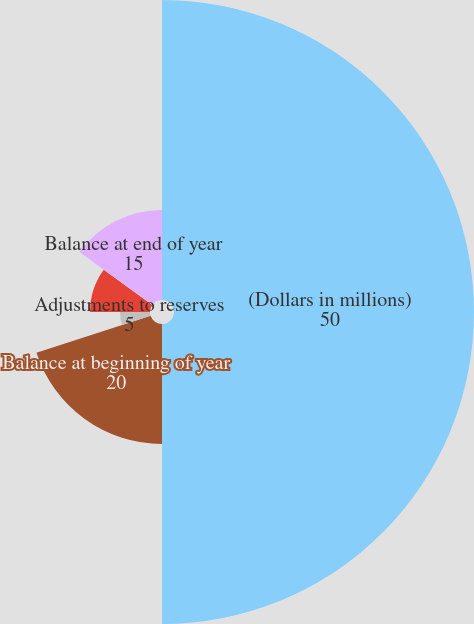Convert chart. <chart><loc_0><loc_0><loc_500><loc_500><pie_chart><fcel>(Dollars in millions)<fcel>Balance at beginning of year<fcel>Liabilities assumed<fcel>Adjustments to reserves<fcel>Benefits paid in the current<fcel>Balance at end of year<nl><fcel>50.0%<fcel>20.0%<fcel>0.0%<fcel>5.0%<fcel>10.0%<fcel>15.0%<nl></chart> 